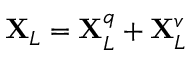Convert formula to latex. <formula><loc_0><loc_0><loc_500><loc_500>X _ { L } = X _ { L } ^ { q } + X _ { L } ^ { v }</formula> 